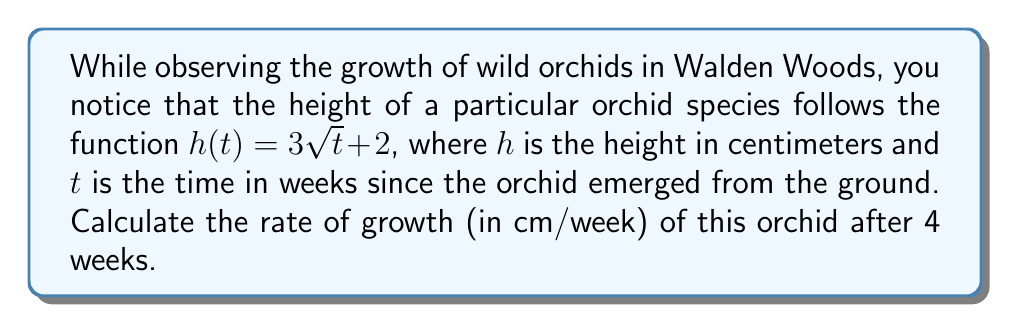Help me with this question. To find the rate of growth, we need to calculate the derivative of the height function $h(t)$ with respect to time $t$, and then evaluate it at $t = 4$ weeks.

Step 1: Find the derivative of $h(t)$.
$$h(t) = 3\sqrt{t} + 2$$
$$h'(t) = 3 \cdot \frac{1}{2\sqrt{t}} = \frac{3}{2\sqrt{t}}$$

Step 2: Evaluate $h'(t)$ at $t = 4$ weeks.
$$h'(4) = \frac{3}{2\sqrt{4}} = \frac{3}{2 \cdot 2} = \frac{3}{4} = 0.75$$

Therefore, after 4 weeks, the orchid is growing at a rate of 0.75 cm per week.
Answer: 0.75 cm/week 